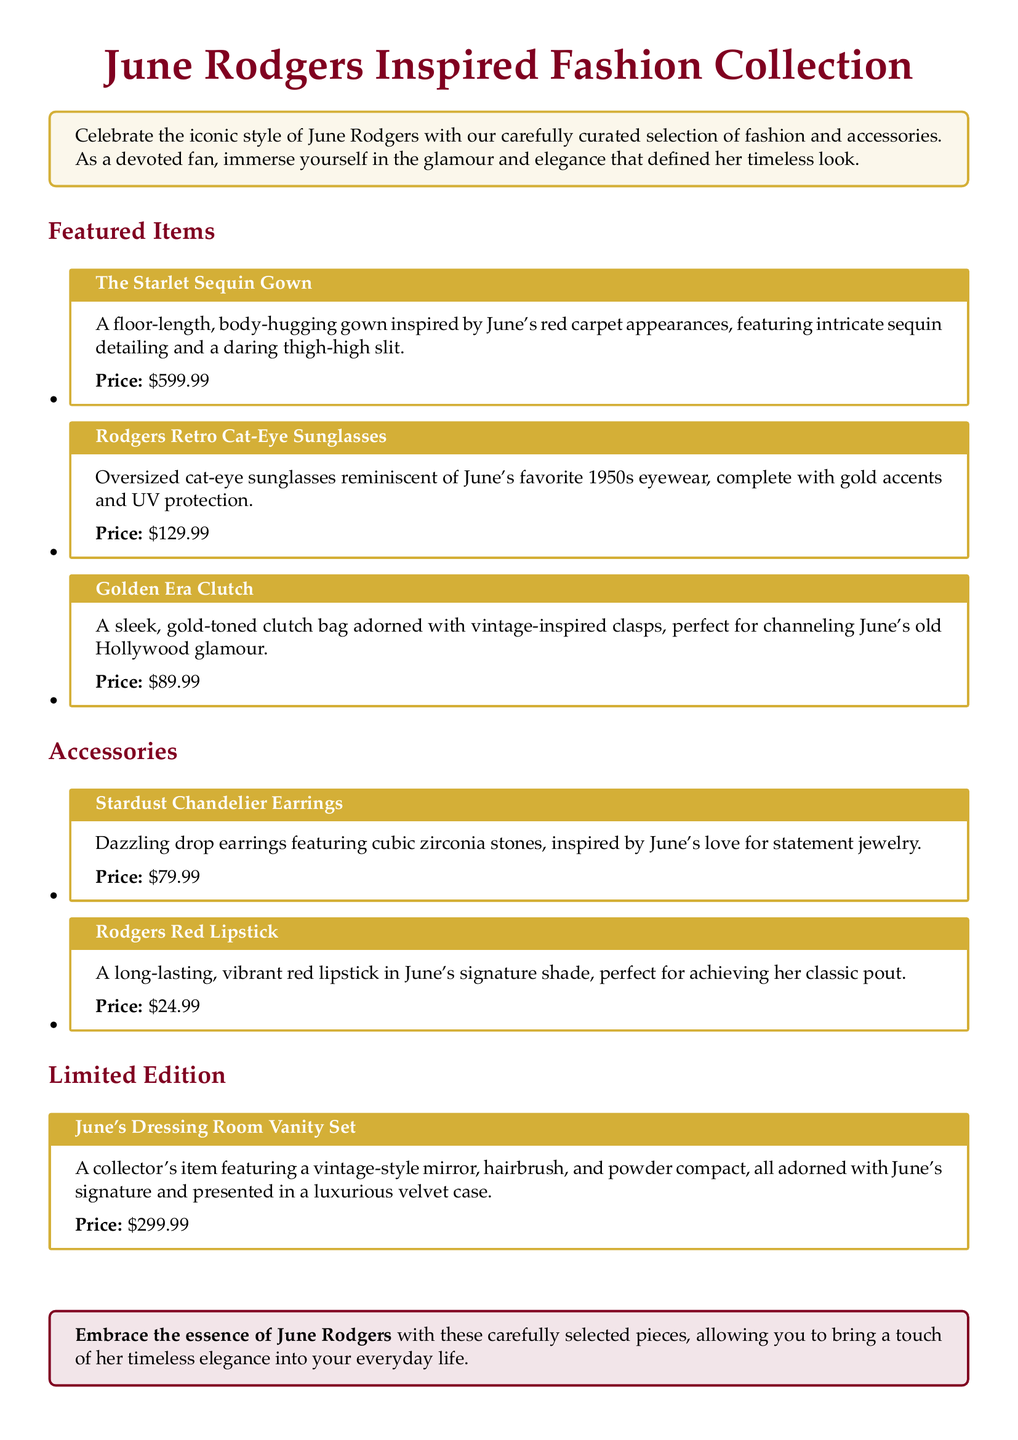what is the name of the featured gown? The name of the featured gown is "The Starlet Sequin Gown."
Answer: The Starlet Sequin Gown how much do the Rodgers Retro Cat-Eye Sunglasses cost? The cost of the Rodgers Retro Cat-Eye Sunglasses is specified in the document.
Answer: $129.99 what type of jewelry is inspired by June's style? The document lists earrings inspired by June's style, specifically mentioning chandelier earrings.
Answer: Chandelier Earrings which item is a collector's edition? The collector's edition item is clearly identified in the document.
Answer: June's Dressing Room Vanity Set what color is June's signature lipstick? The document mentions the color of June's lipstick as vibrant red.
Answer: Red 